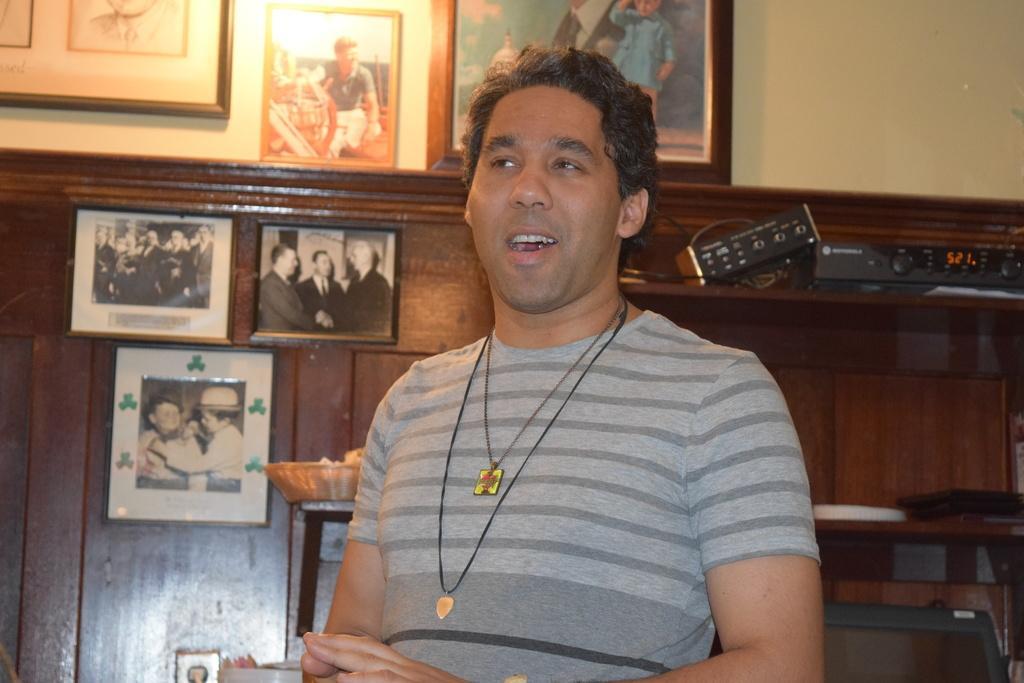Could you give a brief overview of what you see in this image? This is an inside view. In the middle of the image there is a mean wearing t-shirt and speaking by looking at the left side. At the back of this man there are few photo frames are attached to the wall and a wooden plank. On the right side there are some electronic devices are placed on a table. 